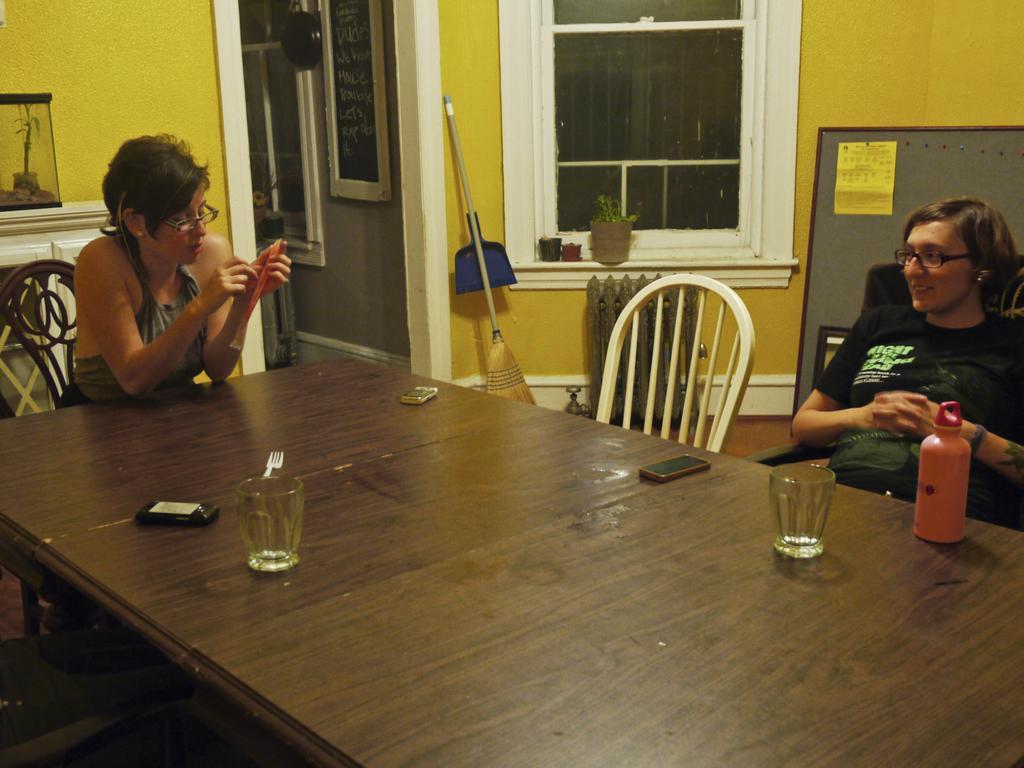Can you describe this image briefly? In this picture there are two women's. This women seeing on his phone and she is smiling while seeing her. They both sat on the chair. On the table there is a mobile, bottle and two glasses. On the top there is a window. On the left side there is a frame. Here it's a door. On left side there is a board which having a paper on it. 